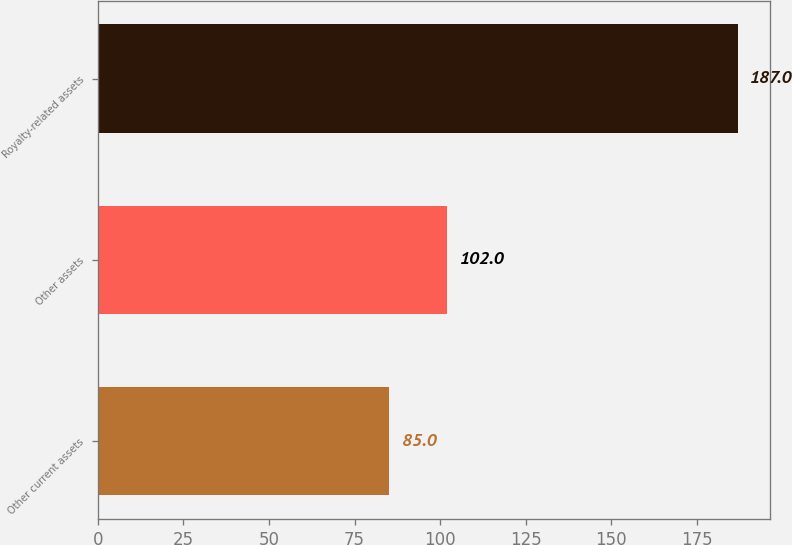<chart> <loc_0><loc_0><loc_500><loc_500><bar_chart><fcel>Other current assets<fcel>Other assets<fcel>Royalty-related assets<nl><fcel>85<fcel>102<fcel>187<nl></chart> 